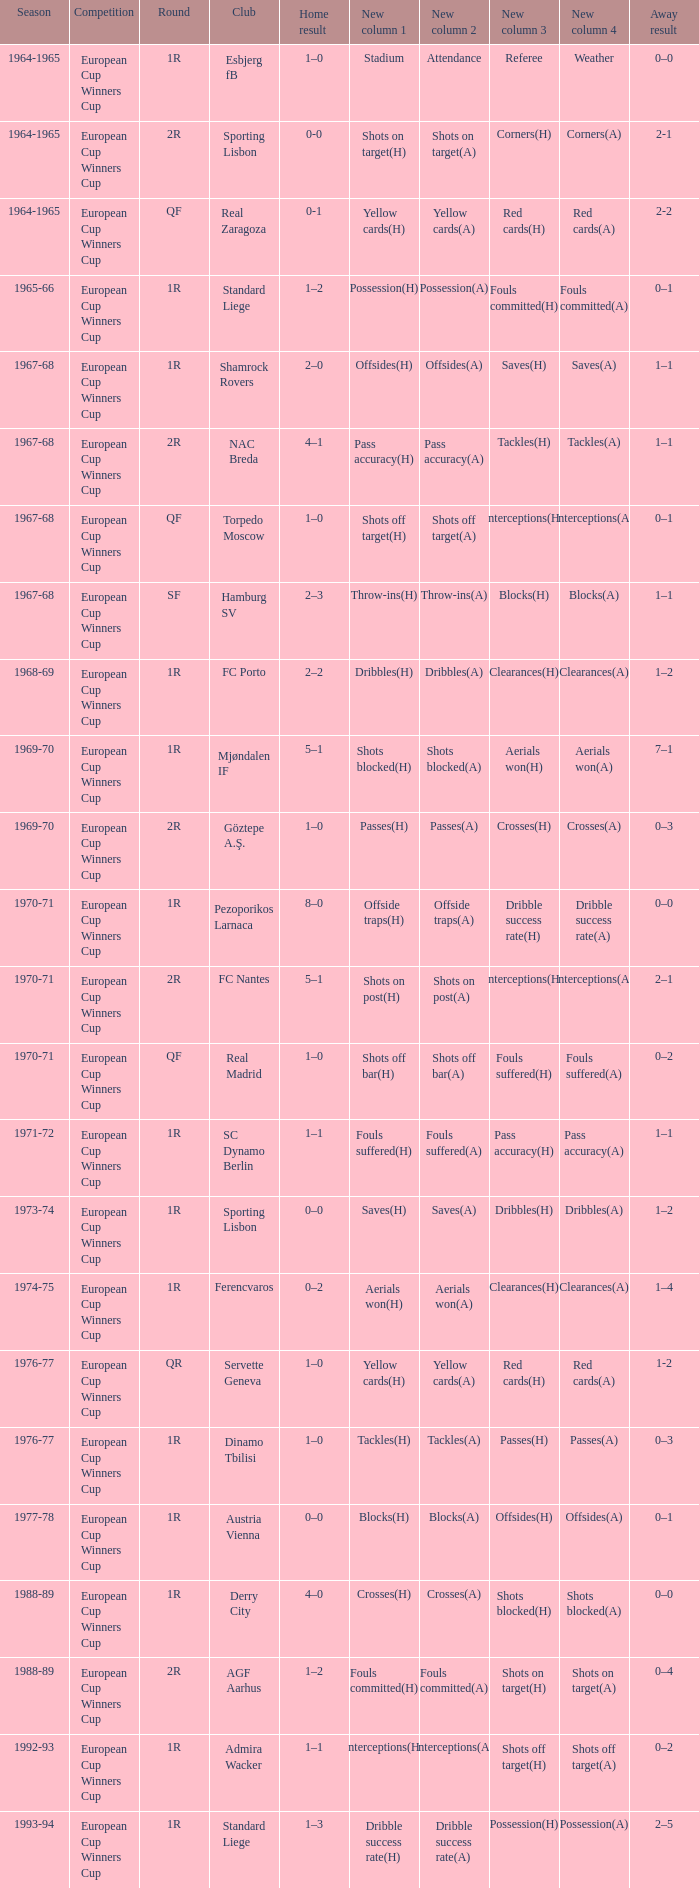Round of 2r, and a Home result of 0-0 has what season? 1964-1965. 